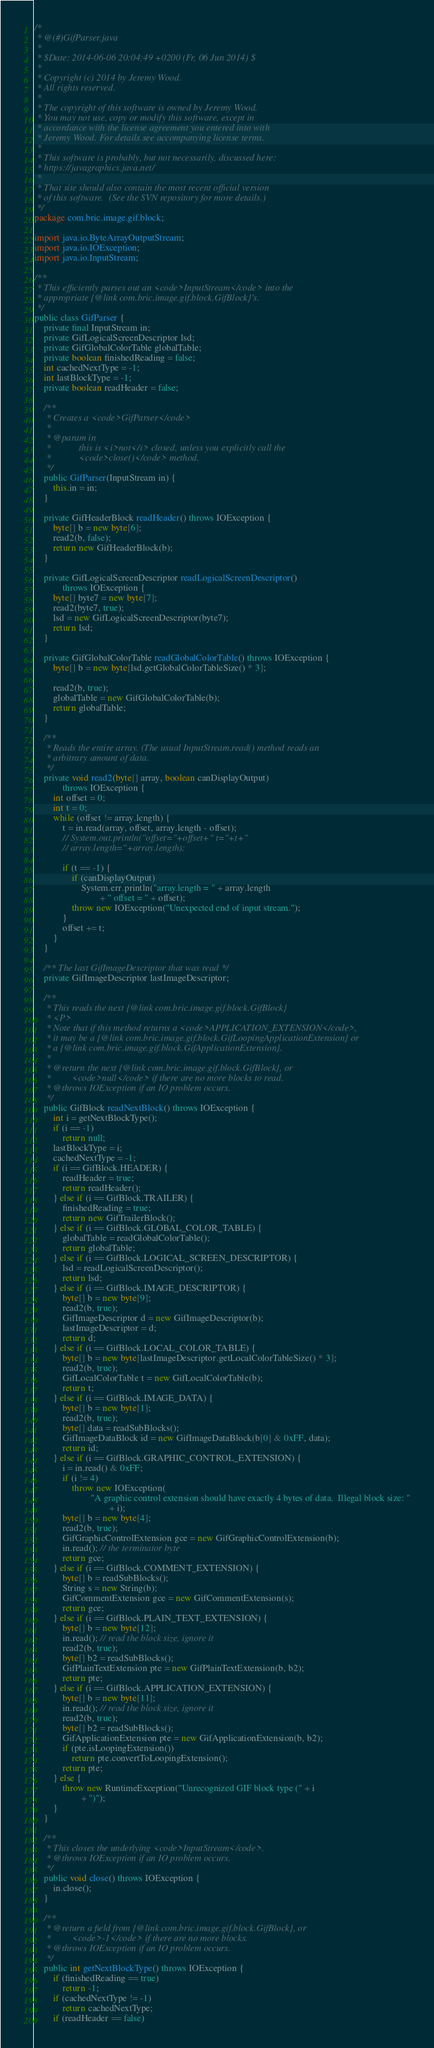<code> <loc_0><loc_0><loc_500><loc_500><_Java_>/*
 * @(#)GifParser.java
 *
 * $Date: 2014-06-06 20:04:49 +0200 (Fr, 06 Jun 2014) $
 *
 * Copyright (c) 2014 by Jeremy Wood.
 * All rights reserved.
 *
 * The copyright of this software is owned by Jeremy Wood. 
 * You may not use, copy or modify this software, except in  
 * accordance with the license agreement you entered into with  
 * Jeremy Wood. For details see accompanying license terms.
 * 
 * This software is probably, but not necessarily, discussed here:
 * https://javagraphics.java.net/
 * 
 * That site should also contain the most recent official version
 * of this software.  (See the SVN repository for more details.)
 */
package com.bric.image.gif.block;

import java.io.ByteArrayOutputStream;
import java.io.IOException;
import java.io.InputStream;

/**
 * This efficiently parses out an <code>InputStream</code> into the
 * appropriate {@link com.bric.image.gif.block.GifBlock}'s.
 */
public class GifParser {
	private final InputStream in;
	private GifLogicalScreenDescriptor lsd;
	private GifGlobalColorTable globalTable;
	private boolean finishedReading = false;
	int cachedNextType = -1;
	int lastBlockType = -1;
	private boolean readHeader = false;

	/**
	 * Creates a <code>GifParser</code>
	 * 
	 * @param in
	 *            this is <i>not</i> closed, unless you explicitly call the
	 *            <code>close()</code> method.
	 */
	public GifParser(InputStream in) {
		this.in = in;
	}

	private GifHeaderBlock readHeader() throws IOException {
		byte[] b = new byte[6];
		read2(b, false);
		return new GifHeaderBlock(b);
	}

	private GifLogicalScreenDescriptor readLogicalScreenDescriptor()
			throws IOException {
		byte[] byte7 = new byte[7];
		read2(byte7, true);
		lsd = new GifLogicalScreenDescriptor(byte7);
		return lsd;
	}

	private GifGlobalColorTable readGlobalColorTable() throws IOException {
		byte[] b = new byte[lsd.getGlobalColorTableSize() * 3];

		read2(b, true);
		globalTable = new GifGlobalColorTable(b);
		return globalTable;
	}

	/**
	 * Reads the entire array. (The usual InputStream.read() method reads an
	 * arbitrary amount of data.
	 */
	private void read2(byte[] array, boolean canDisplayOutput)
			throws IOException {
		int offset = 0;
		int t = 0;
		while (offset != array.length) {
			t = in.read(array, offset, array.length - offset);
			// System.out.println("offset="+offset+" t="+t+"
			// array.length="+array.length);

			if (t == -1) {
				if (canDisplayOutput)
					System.err.println("array.length = " + array.length
							+ " offset = " + offset);
				throw new IOException("Unexpected end of input stream.");
			}
			offset += t;
		}
	}

	/** The last GifImageDescriptor that was read */
	private GifImageDescriptor lastImageDescriptor;

	/**
	 * This reads the next {@link com.bric.image.gif.block.GifBlock}
	 * <P>
	 * Note that if this method returns a <code>APPLICATION_EXTENSION</code>,
	 * it may be a {@link com.bric.image.gif.block.GifLoopingApplicationExtension} or
	 * a {@link com.bric.image.gif.block.GifApplicationExtension}.
	 * 
	 * @return the next {@link com.bric.image.gif.block.GifBlock}, or
	 *         <code>null</code> if there are no more blocks to read.
	 * @throws IOException if an IO problem occurs.
	 */
	public GifBlock readNextBlock() throws IOException {
		int i = getNextBlockType();
		if (i == -1)
			return null;
		lastBlockType = i;
		cachedNextType = -1;
		if (i == GifBlock.HEADER) {
			readHeader = true;
			return readHeader();
		} else if (i == GifBlock.TRAILER) {
			finishedReading = true;
			return new GifTrailerBlock();
		} else if (i == GifBlock.GLOBAL_COLOR_TABLE) {
			globalTable = readGlobalColorTable();
			return globalTable;
		} else if (i == GifBlock.LOGICAL_SCREEN_DESCRIPTOR) {
			lsd = readLogicalScreenDescriptor();
			return lsd;
		} else if (i == GifBlock.IMAGE_DESCRIPTOR) {
			byte[] b = new byte[9];
			read2(b, true);
			GifImageDescriptor d = new GifImageDescriptor(b);
			lastImageDescriptor = d;
			return d;
		} else if (i == GifBlock.LOCAL_COLOR_TABLE) {
			byte[] b = new byte[lastImageDescriptor.getLocalColorTableSize() * 3];
			read2(b, true);
			GifLocalColorTable t = new GifLocalColorTable(b);
			return t;
		} else if (i == GifBlock.IMAGE_DATA) {
			byte[] b = new byte[1];
			read2(b, true);
			byte[] data = readSubBlocks();
			GifImageDataBlock id = new GifImageDataBlock(b[0] & 0xFF, data);
			return id;
		} else if (i == GifBlock.GRAPHIC_CONTROL_EXTENSION) {
			i = in.read() & 0xFF;
			if (i != 4)
				throw new IOException(
						"A graphic control extension should have exactly 4 bytes of data.  Illegal block size: "
								+ i);
			byte[] b = new byte[4];
			read2(b, true);
			GifGraphicControlExtension gce = new GifGraphicControlExtension(b);
			in.read(); // the terminator byte
			return gce;
		} else if (i == GifBlock.COMMENT_EXTENSION) {
			byte[] b = readSubBlocks();
			String s = new String(b);
			GifCommentExtension gce = new GifCommentExtension(s);
			return gce;
		} else if (i == GifBlock.PLAIN_TEXT_EXTENSION) {
			byte[] b = new byte[12];
			in.read(); // read the block size, ignore it
			read2(b, true);
			byte[] b2 = readSubBlocks();
			GifPlainTextExtension pte = new GifPlainTextExtension(b, b2);
			return pte;
		} else if (i == GifBlock.APPLICATION_EXTENSION) {
			byte[] b = new byte[11];
			in.read(); // read the block size, ignore it
			read2(b, true);
			byte[] b2 = readSubBlocks();
			GifApplicationExtension pte = new GifApplicationExtension(b, b2);
			if (pte.isLoopingExtension())
				return pte.convertToLoopingExtension();
			return pte;
		} else {
			throw new RuntimeException("Unrecognized GIF block type (" + i
					+ ")");
		}
	}

	/**
	 * This closes the underlying <code>InputStream</code>.
	 * @throws IOException if an IO problem occurs.
	 */
	public void close() throws IOException {
		in.close();
	}

	/**
	 * @return a field from {@link com.bric.image.gif.block.GifBlock}, or
	 *         <code>-1</code> if there are no more blocks.
	 * @throws IOException if an IO problem occurs.
	 */
	public int getNextBlockType() throws IOException {
		if (finishedReading == true)
			return -1;
		if (cachedNextType != -1)
			return cachedNextType;
		if (readHeader == false)</code> 